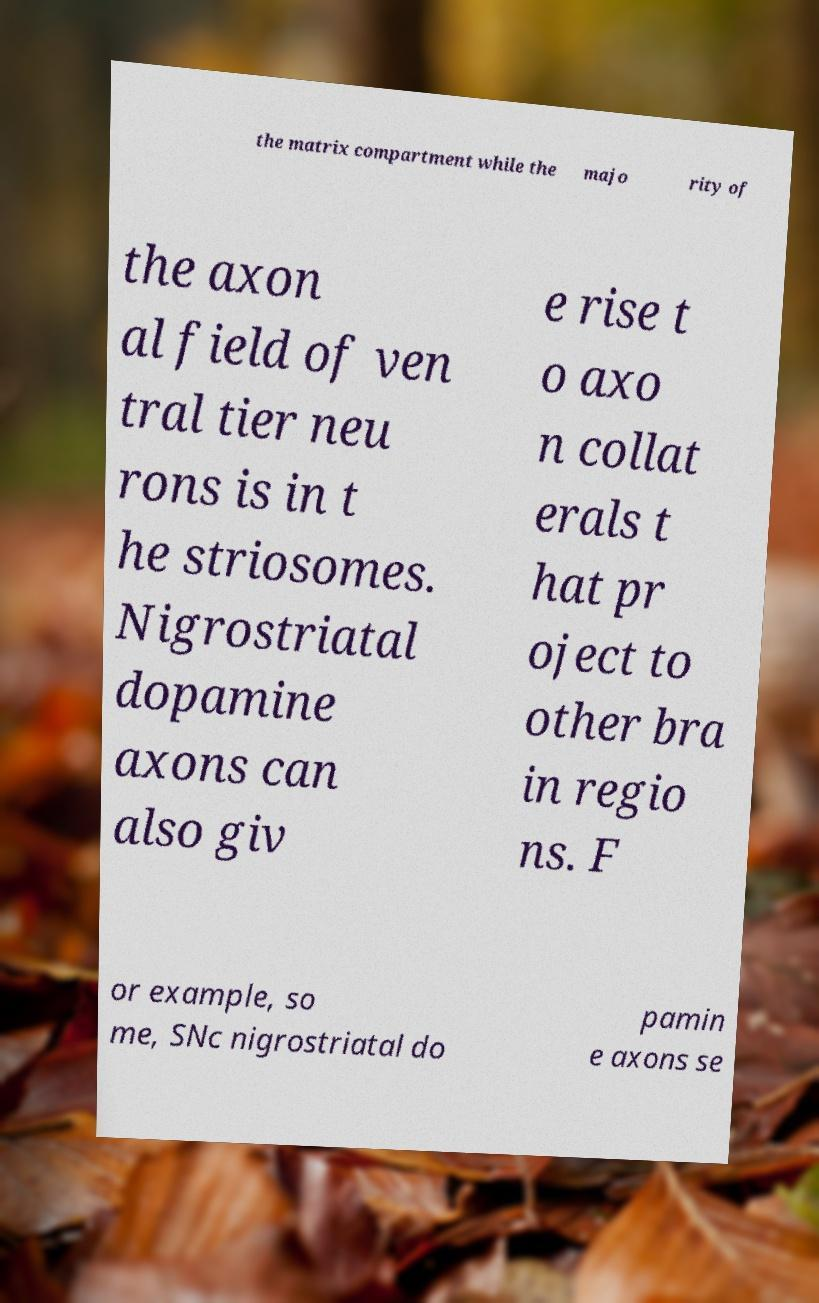Please read and relay the text visible in this image. What does it say? the matrix compartment while the majo rity of the axon al field of ven tral tier neu rons is in t he striosomes. Nigrostriatal dopamine axons can also giv e rise t o axo n collat erals t hat pr oject to other bra in regio ns. F or example, so me, SNc nigrostriatal do pamin e axons se 